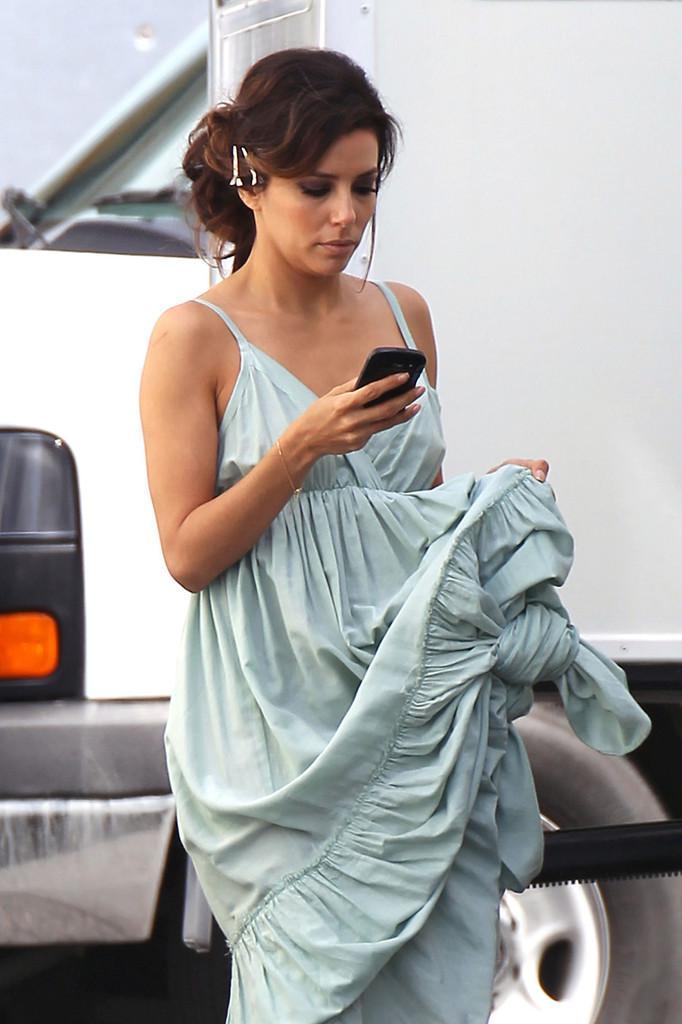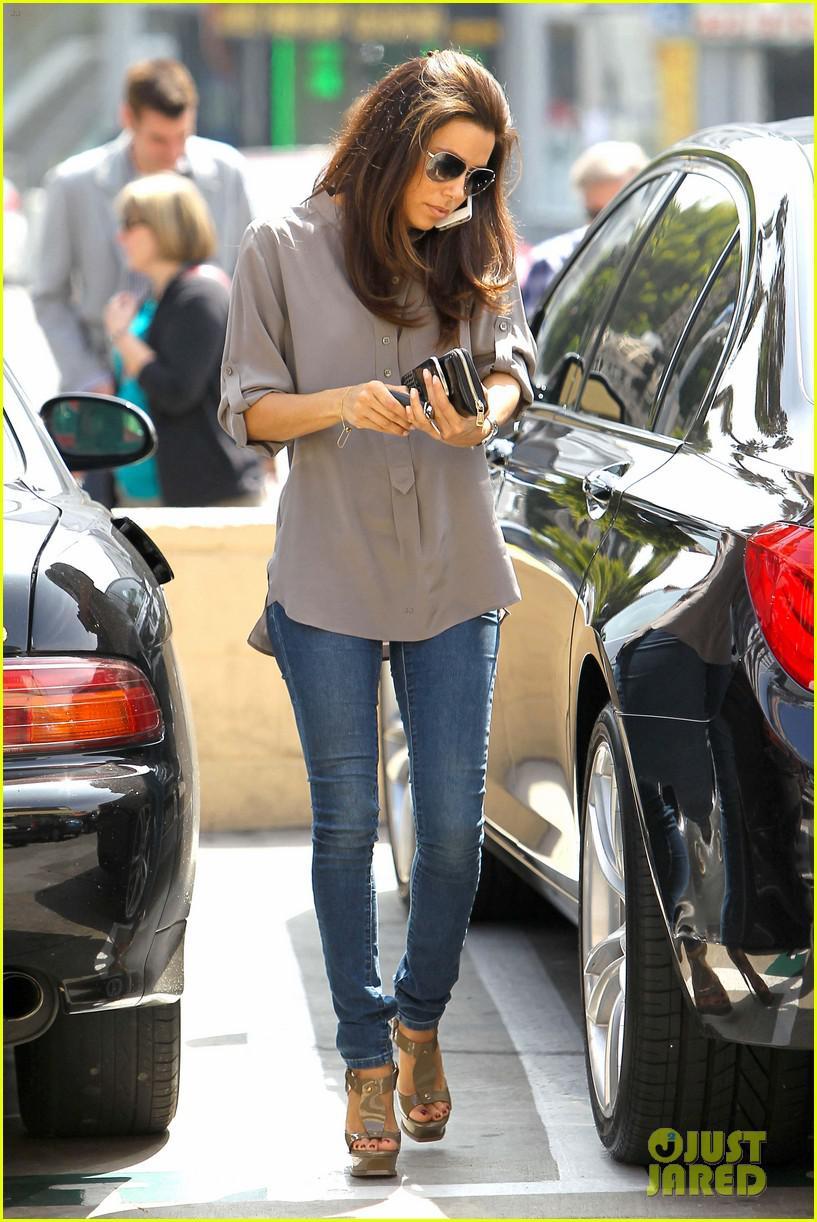The first image is the image on the left, the second image is the image on the right. Considering the images on both sides, is "A woman is holding a cellphone to her face using her left hand." valid? Answer yes or no. No. 